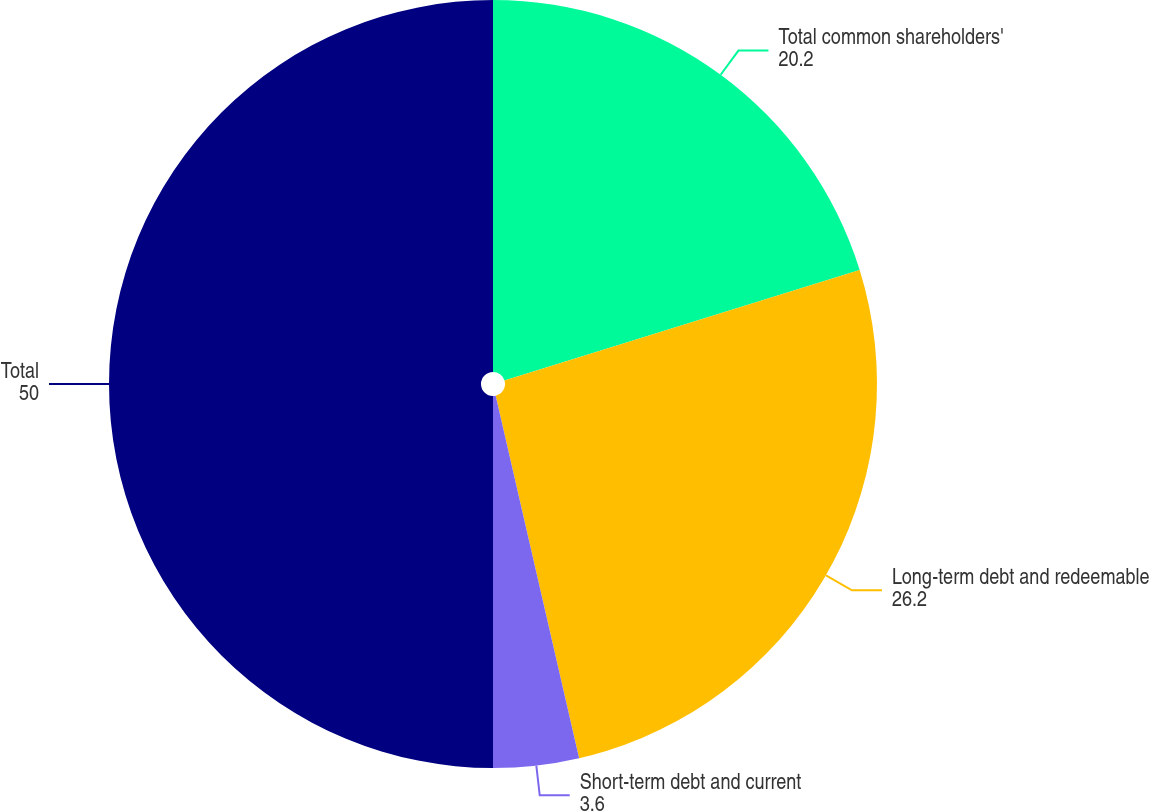Convert chart to OTSL. <chart><loc_0><loc_0><loc_500><loc_500><pie_chart><fcel>Total common shareholders'<fcel>Long-term debt and redeemable<fcel>Short-term debt and current<fcel>Total<nl><fcel>20.2%<fcel>26.2%<fcel>3.6%<fcel>50.0%<nl></chart> 